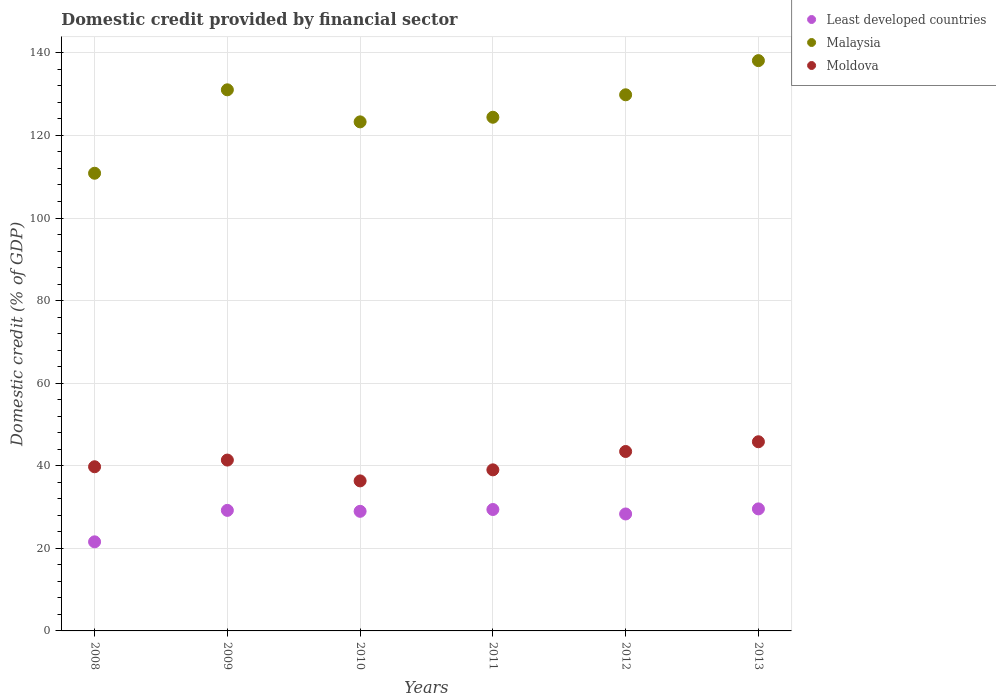What is the domestic credit in Malaysia in 2010?
Make the answer very short. 123.29. Across all years, what is the maximum domestic credit in Malaysia?
Give a very brief answer. 138.12. Across all years, what is the minimum domestic credit in Moldova?
Offer a very short reply. 36.34. In which year was the domestic credit in Malaysia maximum?
Provide a short and direct response. 2013. What is the total domestic credit in Moldova in the graph?
Provide a short and direct response. 245.76. What is the difference between the domestic credit in Moldova in 2010 and that in 2012?
Provide a succinct answer. -7.12. What is the difference between the domestic credit in Moldova in 2013 and the domestic credit in Least developed countries in 2010?
Offer a terse response. 16.85. What is the average domestic credit in Moldova per year?
Provide a succinct answer. 40.96. In the year 2013, what is the difference between the domestic credit in Malaysia and domestic credit in Moldova?
Make the answer very short. 92.31. What is the ratio of the domestic credit in Malaysia in 2009 to that in 2011?
Ensure brevity in your answer.  1.05. What is the difference between the highest and the second highest domestic credit in Malaysia?
Offer a terse response. 7.07. What is the difference between the highest and the lowest domestic credit in Malaysia?
Your answer should be compact. 27.27. In how many years, is the domestic credit in Malaysia greater than the average domestic credit in Malaysia taken over all years?
Ensure brevity in your answer.  3. Is the sum of the domestic credit in Moldova in 2011 and 2013 greater than the maximum domestic credit in Least developed countries across all years?
Provide a succinct answer. Yes. Does the domestic credit in Least developed countries monotonically increase over the years?
Give a very brief answer. No. Is the domestic credit in Least developed countries strictly greater than the domestic credit in Malaysia over the years?
Give a very brief answer. No. What is the difference between two consecutive major ticks on the Y-axis?
Offer a terse response. 20. Are the values on the major ticks of Y-axis written in scientific E-notation?
Keep it short and to the point. No. Does the graph contain any zero values?
Ensure brevity in your answer.  No. Does the graph contain grids?
Ensure brevity in your answer.  Yes. Where does the legend appear in the graph?
Ensure brevity in your answer.  Top right. How many legend labels are there?
Offer a terse response. 3. What is the title of the graph?
Your answer should be very brief. Domestic credit provided by financial sector. What is the label or title of the X-axis?
Keep it short and to the point. Years. What is the label or title of the Y-axis?
Ensure brevity in your answer.  Domestic credit (% of GDP). What is the Domestic credit (% of GDP) of Least developed countries in 2008?
Provide a short and direct response. 21.58. What is the Domestic credit (% of GDP) of Malaysia in 2008?
Give a very brief answer. 110.85. What is the Domestic credit (% of GDP) in Moldova in 2008?
Make the answer very short. 39.76. What is the Domestic credit (% of GDP) of Least developed countries in 2009?
Provide a succinct answer. 29.19. What is the Domestic credit (% of GDP) of Malaysia in 2009?
Your answer should be compact. 131.05. What is the Domestic credit (% of GDP) in Moldova in 2009?
Offer a very short reply. 41.38. What is the Domestic credit (% of GDP) of Least developed countries in 2010?
Give a very brief answer. 28.97. What is the Domestic credit (% of GDP) in Malaysia in 2010?
Make the answer very short. 123.29. What is the Domestic credit (% of GDP) in Moldova in 2010?
Your answer should be compact. 36.34. What is the Domestic credit (% of GDP) in Least developed countries in 2011?
Provide a succinct answer. 29.41. What is the Domestic credit (% of GDP) in Malaysia in 2011?
Give a very brief answer. 124.41. What is the Domestic credit (% of GDP) of Moldova in 2011?
Make the answer very short. 39.01. What is the Domestic credit (% of GDP) in Least developed countries in 2012?
Ensure brevity in your answer.  28.33. What is the Domestic credit (% of GDP) of Malaysia in 2012?
Offer a terse response. 129.85. What is the Domestic credit (% of GDP) of Moldova in 2012?
Provide a succinct answer. 43.46. What is the Domestic credit (% of GDP) of Least developed countries in 2013?
Ensure brevity in your answer.  29.55. What is the Domestic credit (% of GDP) of Malaysia in 2013?
Give a very brief answer. 138.12. What is the Domestic credit (% of GDP) of Moldova in 2013?
Make the answer very short. 45.81. Across all years, what is the maximum Domestic credit (% of GDP) in Least developed countries?
Your answer should be very brief. 29.55. Across all years, what is the maximum Domestic credit (% of GDP) of Malaysia?
Offer a very short reply. 138.12. Across all years, what is the maximum Domestic credit (% of GDP) in Moldova?
Your response must be concise. 45.81. Across all years, what is the minimum Domestic credit (% of GDP) in Least developed countries?
Give a very brief answer. 21.58. Across all years, what is the minimum Domestic credit (% of GDP) of Malaysia?
Offer a very short reply. 110.85. Across all years, what is the minimum Domestic credit (% of GDP) of Moldova?
Your answer should be very brief. 36.34. What is the total Domestic credit (% of GDP) in Least developed countries in the graph?
Ensure brevity in your answer.  167.03. What is the total Domestic credit (% of GDP) of Malaysia in the graph?
Keep it short and to the point. 757.57. What is the total Domestic credit (% of GDP) of Moldova in the graph?
Provide a succinct answer. 245.76. What is the difference between the Domestic credit (% of GDP) in Least developed countries in 2008 and that in 2009?
Keep it short and to the point. -7.62. What is the difference between the Domestic credit (% of GDP) in Malaysia in 2008 and that in 2009?
Provide a succinct answer. -20.2. What is the difference between the Domestic credit (% of GDP) in Moldova in 2008 and that in 2009?
Keep it short and to the point. -1.62. What is the difference between the Domestic credit (% of GDP) in Least developed countries in 2008 and that in 2010?
Provide a short and direct response. -7.39. What is the difference between the Domestic credit (% of GDP) of Malaysia in 2008 and that in 2010?
Offer a very short reply. -12.44. What is the difference between the Domestic credit (% of GDP) in Moldova in 2008 and that in 2010?
Offer a terse response. 3.42. What is the difference between the Domestic credit (% of GDP) of Least developed countries in 2008 and that in 2011?
Offer a terse response. -7.83. What is the difference between the Domestic credit (% of GDP) in Malaysia in 2008 and that in 2011?
Your answer should be compact. -13.56. What is the difference between the Domestic credit (% of GDP) in Moldova in 2008 and that in 2011?
Provide a succinct answer. 0.75. What is the difference between the Domestic credit (% of GDP) of Least developed countries in 2008 and that in 2012?
Provide a succinct answer. -6.75. What is the difference between the Domestic credit (% of GDP) of Malaysia in 2008 and that in 2012?
Your answer should be compact. -19. What is the difference between the Domestic credit (% of GDP) in Moldova in 2008 and that in 2012?
Keep it short and to the point. -3.7. What is the difference between the Domestic credit (% of GDP) of Least developed countries in 2008 and that in 2013?
Provide a short and direct response. -7.98. What is the difference between the Domestic credit (% of GDP) in Malaysia in 2008 and that in 2013?
Keep it short and to the point. -27.27. What is the difference between the Domestic credit (% of GDP) in Moldova in 2008 and that in 2013?
Make the answer very short. -6.05. What is the difference between the Domestic credit (% of GDP) of Least developed countries in 2009 and that in 2010?
Offer a very short reply. 0.23. What is the difference between the Domestic credit (% of GDP) of Malaysia in 2009 and that in 2010?
Keep it short and to the point. 7.76. What is the difference between the Domestic credit (% of GDP) in Moldova in 2009 and that in 2010?
Offer a terse response. 5.04. What is the difference between the Domestic credit (% of GDP) in Least developed countries in 2009 and that in 2011?
Keep it short and to the point. -0.21. What is the difference between the Domestic credit (% of GDP) of Malaysia in 2009 and that in 2011?
Offer a very short reply. 6.65. What is the difference between the Domestic credit (% of GDP) of Moldova in 2009 and that in 2011?
Your response must be concise. 2.37. What is the difference between the Domestic credit (% of GDP) of Least developed countries in 2009 and that in 2012?
Keep it short and to the point. 0.87. What is the difference between the Domestic credit (% of GDP) of Malaysia in 2009 and that in 2012?
Make the answer very short. 1.21. What is the difference between the Domestic credit (% of GDP) in Moldova in 2009 and that in 2012?
Provide a short and direct response. -2.08. What is the difference between the Domestic credit (% of GDP) of Least developed countries in 2009 and that in 2013?
Make the answer very short. -0.36. What is the difference between the Domestic credit (% of GDP) in Malaysia in 2009 and that in 2013?
Offer a terse response. -7.07. What is the difference between the Domestic credit (% of GDP) of Moldova in 2009 and that in 2013?
Give a very brief answer. -4.43. What is the difference between the Domestic credit (% of GDP) in Least developed countries in 2010 and that in 2011?
Provide a short and direct response. -0.44. What is the difference between the Domestic credit (% of GDP) in Malaysia in 2010 and that in 2011?
Provide a succinct answer. -1.12. What is the difference between the Domestic credit (% of GDP) of Moldova in 2010 and that in 2011?
Offer a terse response. -2.68. What is the difference between the Domestic credit (% of GDP) of Least developed countries in 2010 and that in 2012?
Keep it short and to the point. 0.64. What is the difference between the Domestic credit (% of GDP) in Malaysia in 2010 and that in 2012?
Give a very brief answer. -6.56. What is the difference between the Domestic credit (% of GDP) of Moldova in 2010 and that in 2012?
Ensure brevity in your answer.  -7.12. What is the difference between the Domestic credit (% of GDP) in Least developed countries in 2010 and that in 2013?
Provide a succinct answer. -0.59. What is the difference between the Domestic credit (% of GDP) in Malaysia in 2010 and that in 2013?
Make the answer very short. -14.83. What is the difference between the Domestic credit (% of GDP) in Moldova in 2010 and that in 2013?
Provide a short and direct response. -9.48. What is the difference between the Domestic credit (% of GDP) in Least developed countries in 2011 and that in 2012?
Keep it short and to the point. 1.08. What is the difference between the Domestic credit (% of GDP) in Malaysia in 2011 and that in 2012?
Your answer should be very brief. -5.44. What is the difference between the Domestic credit (% of GDP) of Moldova in 2011 and that in 2012?
Keep it short and to the point. -4.45. What is the difference between the Domestic credit (% of GDP) in Least developed countries in 2011 and that in 2013?
Give a very brief answer. -0.15. What is the difference between the Domestic credit (% of GDP) of Malaysia in 2011 and that in 2013?
Your answer should be compact. -13.71. What is the difference between the Domestic credit (% of GDP) of Moldova in 2011 and that in 2013?
Provide a short and direct response. -6.8. What is the difference between the Domestic credit (% of GDP) of Least developed countries in 2012 and that in 2013?
Your answer should be compact. -1.23. What is the difference between the Domestic credit (% of GDP) of Malaysia in 2012 and that in 2013?
Your answer should be very brief. -8.27. What is the difference between the Domestic credit (% of GDP) of Moldova in 2012 and that in 2013?
Make the answer very short. -2.35. What is the difference between the Domestic credit (% of GDP) of Least developed countries in 2008 and the Domestic credit (% of GDP) of Malaysia in 2009?
Offer a very short reply. -109.48. What is the difference between the Domestic credit (% of GDP) in Least developed countries in 2008 and the Domestic credit (% of GDP) in Moldova in 2009?
Ensure brevity in your answer.  -19.8. What is the difference between the Domestic credit (% of GDP) in Malaysia in 2008 and the Domestic credit (% of GDP) in Moldova in 2009?
Give a very brief answer. 69.47. What is the difference between the Domestic credit (% of GDP) in Least developed countries in 2008 and the Domestic credit (% of GDP) in Malaysia in 2010?
Offer a very short reply. -101.71. What is the difference between the Domestic credit (% of GDP) of Least developed countries in 2008 and the Domestic credit (% of GDP) of Moldova in 2010?
Offer a very short reply. -14.76. What is the difference between the Domestic credit (% of GDP) in Malaysia in 2008 and the Domestic credit (% of GDP) in Moldova in 2010?
Provide a succinct answer. 74.51. What is the difference between the Domestic credit (% of GDP) of Least developed countries in 2008 and the Domestic credit (% of GDP) of Malaysia in 2011?
Give a very brief answer. -102.83. What is the difference between the Domestic credit (% of GDP) of Least developed countries in 2008 and the Domestic credit (% of GDP) of Moldova in 2011?
Make the answer very short. -17.43. What is the difference between the Domestic credit (% of GDP) in Malaysia in 2008 and the Domestic credit (% of GDP) in Moldova in 2011?
Give a very brief answer. 71.84. What is the difference between the Domestic credit (% of GDP) of Least developed countries in 2008 and the Domestic credit (% of GDP) of Malaysia in 2012?
Provide a succinct answer. -108.27. What is the difference between the Domestic credit (% of GDP) in Least developed countries in 2008 and the Domestic credit (% of GDP) in Moldova in 2012?
Make the answer very short. -21.88. What is the difference between the Domestic credit (% of GDP) in Malaysia in 2008 and the Domestic credit (% of GDP) in Moldova in 2012?
Provide a succinct answer. 67.39. What is the difference between the Domestic credit (% of GDP) of Least developed countries in 2008 and the Domestic credit (% of GDP) of Malaysia in 2013?
Keep it short and to the point. -116.54. What is the difference between the Domestic credit (% of GDP) of Least developed countries in 2008 and the Domestic credit (% of GDP) of Moldova in 2013?
Provide a short and direct response. -24.24. What is the difference between the Domestic credit (% of GDP) in Malaysia in 2008 and the Domestic credit (% of GDP) in Moldova in 2013?
Offer a very short reply. 65.03. What is the difference between the Domestic credit (% of GDP) in Least developed countries in 2009 and the Domestic credit (% of GDP) in Malaysia in 2010?
Your answer should be compact. -94.1. What is the difference between the Domestic credit (% of GDP) in Least developed countries in 2009 and the Domestic credit (% of GDP) in Moldova in 2010?
Give a very brief answer. -7.14. What is the difference between the Domestic credit (% of GDP) of Malaysia in 2009 and the Domestic credit (% of GDP) of Moldova in 2010?
Offer a very short reply. 94.72. What is the difference between the Domestic credit (% of GDP) in Least developed countries in 2009 and the Domestic credit (% of GDP) in Malaysia in 2011?
Offer a terse response. -95.21. What is the difference between the Domestic credit (% of GDP) of Least developed countries in 2009 and the Domestic credit (% of GDP) of Moldova in 2011?
Your answer should be compact. -9.82. What is the difference between the Domestic credit (% of GDP) of Malaysia in 2009 and the Domestic credit (% of GDP) of Moldova in 2011?
Ensure brevity in your answer.  92.04. What is the difference between the Domestic credit (% of GDP) in Least developed countries in 2009 and the Domestic credit (% of GDP) in Malaysia in 2012?
Give a very brief answer. -100.65. What is the difference between the Domestic credit (% of GDP) in Least developed countries in 2009 and the Domestic credit (% of GDP) in Moldova in 2012?
Your answer should be very brief. -14.27. What is the difference between the Domestic credit (% of GDP) of Malaysia in 2009 and the Domestic credit (% of GDP) of Moldova in 2012?
Offer a terse response. 87.59. What is the difference between the Domestic credit (% of GDP) in Least developed countries in 2009 and the Domestic credit (% of GDP) in Malaysia in 2013?
Provide a short and direct response. -108.93. What is the difference between the Domestic credit (% of GDP) in Least developed countries in 2009 and the Domestic credit (% of GDP) in Moldova in 2013?
Your response must be concise. -16.62. What is the difference between the Domestic credit (% of GDP) in Malaysia in 2009 and the Domestic credit (% of GDP) in Moldova in 2013?
Offer a terse response. 85.24. What is the difference between the Domestic credit (% of GDP) of Least developed countries in 2010 and the Domestic credit (% of GDP) of Malaysia in 2011?
Ensure brevity in your answer.  -95.44. What is the difference between the Domestic credit (% of GDP) of Least developed countries in 2010 and the Domestic credit (% of GDP) of Moldova in 2011?
Ensure brevity in your answer.  -10.04. What is the difference between the Domestic credit (% of GDP) of Malaysia in 2010 and the Domestic credit (% of GDP) of Moldova in 2011?
Offer a terse response. 84.28. What is the difference between the Domestic credit (% of GDP) in Least developed countries in 2010 and the Domestic credit (% of GDP) in Malaysia in 2012?
Offer a terse response. -100.88. What is the difference between the Domestic credit (% of GDP) in Least developed countries in 2010 and the Domestic credit (% of GDP) in Moldova in 2012?
Your answer should be very brief. -14.49. What is the difference between the Domestic credit (% of GDP) in Malaysia in 2010 and the Domestic credit (% of GDP) in Moldova in 2012?
Give a very brief answer. 79.83. What is the difference between the Domestic credit (% of GDP) of Least developed countries in 2010 and the Domestic credit (% of GDP) of Malaysia in 2013?
Provide a succinct answer. -109.15. What is the difference between the Domestic credit (% of GDP) of Least developed countries in 2010 and the Domestic credit (% of GDP) of Moldova in 2013?
Provide a succinct answer. -16.85. What is the difference between the Domestic credit (% of GDP) of Malaysia in 2010 and the Domestic credit (% of GDP) of Moldova in 2013?
Make the answer very short. 77.48. What is the difference between the Domestic credit (% of GDP) of Least developed countries in 2011 and the Domestic credit (% of GDP) of Malaysia in 2012?
Give a very brief answer. -100.44. What is the difference between the Domestic credit (% of GDP) in Least developed countries in 2011 and the Domestic credit (% of GDP) in Moldova in 2012?
Ensure brevity in your answer.  -14.05. What is the difference between the Domestic credit (% of GDP) of Malaysia in 2011 and the Domestic credit (% of GDP) of Moldova in 2012?
Give a very brief answer. 80.95. What is the difference between the Domestic credit (% of GDP) of Least developed countries in 2011 and the Domestic credit (% of GDP) of Malaysia in 2013?
Give a very brief answer. -108.71. What is the difference between the Domestic credit (% of GDP) of Least developed countries in 2011 and the Domestic credit (% of GDP) of Moldova in 2013?
Provide a short and direct response. -16.41. What is the difference between the Domestic credit (% of GDP) of Malaysia in 2011 and the Domestic credit (% of GDP) of Moldova in 2013?
Provide a succinct answer. 78.59. What is the difference between the Domestic credit (% of GDP) of Least developed countries in 2012 and the Domestic credit (% of GDP) of Malaysia in 2013?
Provide a succinct answer. -109.79. What is the difference between the Domestic credit (% of GDP) in Least developed countries in 2012 and the Domestic credit (% of GDP) in Moldova in 2013?
Ensure brevity in your answer.  -17.49. What is the difference between the Domestic credit (% of GDP) of Malaysia in 2012 and the Domestic credit (% of GDP) of Moldova in 2013?
Provide a succinct answer. 84.03. What is the average Domestic credit (% of GDP) in Least developed countries per year?
Offer a terse response. 27.84. What is the average Domestic credit (% of GDP) of Malaysia per year?
Offer a very short reply. 126.26. What is the average Domestic credit (% of GDP) of Moldova per year?
Ensure brevity in your answer.  40.96. In the year 2008, what is the difference between the Domestic credit (% of GDP) in Least developed countries and Domestic credit (% of GDP) in Malaysia?
Make the answer very short. -89.27. In the year 2008, what is the difference between the Domestic credit (% of GDP) in Least developed countries and Domestic credit (% of GDP) in Moldova?
Offer a very short reply. -18.18. In the year 2008, what is the difference between the Domestic credit (% of GDP) of Malaysia and Domestic credit (% of GDP) of Moldova?
Provide a succinct answer. 71.09. In the year 2009, what is the difference between the Domestic credit (% of GDP) of Least developed countries and Domestic credit (% of GDP) of Malaysia?
Your response must be concise. -101.86. In the year 2009, what is the difference between the Domestic credit (% of GDP) of Least developed countries and Domestic credit (% of GDP) of Moldova?
Offer a very short reply. -12.19. In the year 2009, what is the difference between the Domestic credit (% of GDP) in Malaysia and Domestic credit (% of GDP) in Moldova?
Your answer should be very brief. 89.67. In the year 2010, what is the difference between the Domestic credit (% of GDP) in Least developed countries and Domestic credit (% of GDP) in Malaysia?
Your answer should be very brief. -94.32. In the year 2010, what is the difference between the Domestic credit (% of GDP) of Least developed countries and Domestic credit (% of GDP) of Moldova?
Offer a terse response. -7.37. In the year 2010, what is the difference between the Domestic credit (% of GDP) of Malaysia and Domestic credit (% of GDP) of Moldova?
Ensure brevity in your answer.  86.96. In the year 2011, what is the difference between the Domestic credit (% of GDP) of Least developed countries and Domestic credit (% of GDP) of Malaysia?
Provide a short and direct response. -95. In the year 2011, what is the difference between the Domestic credit (% of GDP) in Least developed countries and Domestic credit (% of GDP) in Moldova?
Your answer should be compact. -9.6. In the year 2011, what is the difference between the Domestic credit (% of GDP) in Malaysia and Domestic credit (% of GDP) in Moldova?
Keep it short and to the point. 85.4. In the year 2012, what is the difference between the Domestic credit (% of GDP) of Least developed countries and Domestic credit (% of GDP) of Malaysia?
Give a very brief answer. -101.52. In the year 2012, what is the difference between the Domestic credit (% of GDP) of Least developed countries and Domestic credit (% of GDP) of Moldova?
Your answer should be very brief. -15.13. In the year 2012, what is the difference between the Domestic credit (% of GDP) of Malaysia and Domestic credit (% of GDP) of Moldova?
Your answer should be very brief. 86.39. In the year 2013, what is the difference between the Domestic credit (% of GDP) in Least developed countries and Domestic credit (% of GDP) in Malaysia?
Give a very brief answer. -108.57. In the year 2013, what is the difference between the Domestic credit (% of GDP) in Least developed countries and Domestic credit (% of GDP) in Moldova?
Your answer should be very brief. -16.26. In the year 2013, what is the difference between the Domestic credit (% of GDP) in Malaysia and Domestic credit (% of GDP) in Moldova?
Offer a terse response. 92.31. What is the ratio of the Domestic credit (% of GDP) in Least developed countries in 2008 to that in 2009?
Keep it short and to the point. 0.74. What is the ratio of the Domestic credit (% of GDP) of Malaysia in 2008 to that in 2009?
Your answer should be compact. 0.85. What is the ratio of the Domestic credit (% of GDP) of Moldova in 2008 to that in 2009?
Ensure brevity in your answer.  0.96. What is the ratio of the Domestic credit (% of GDP) of Least developed countries in 2008 to that in 2010?
Keep it short and to the point. 0.74. What is the ratio of the Domestic credit (% of GDP) in Malaysia in 2008 to that in 2010?
Your response must be concise. 0.9. What is the ratio of the Domestic credit (% of GDP) in Moldova in 2008 to that in 2010?
Provide a succinct answer. 1.09. What is the ratio of the Domestic credit (% of GDP) of Least developed countries in 2008 to that in 2011?
Your answer should be compact. 0.73. What is the ratio of the Domestic credit (% of GDP) of Malaysia in 2008 to that in 2011?
Your response must be concise. 0.89. What is the ratio of the Domestic credit (% of GDP) of Moldova in 2008 to that in 2011?
Make the answer very short. 1.02. What is the ratio of the Domestic credit (% of GDP) of Least developed countries in 2008 to that in 2012?
Make the answer very short. 0.76. What is the ratio of the Domestic credit (% of GDP) of Malaysia in 2008 to that in 2012?
Your answer should be compact. 0.85. What is the ratio of the Domestic credit (% of GDP) in Moldova in 2008 to that in 2012?
Your response must be concise. 0.91. What is the ratio of the Domestic credit (% of GDP) of Least developed countries in 2008 to that in 2013?
Make the answer very short. 0.73. What is the ratio of the Domestic credit (% of GDP) of Malaysia in 2008 to that in 2013?
Provide a short and direct response. 0.8. What is the ratio of the Domestic credit (% of GDP) of Moldova in 2008 to that in 2013?
Keep it short and to the point. 0.87. What is the ratio of the Domestic credit (% of GDP) in Least developed countries in 2009 to that in 2010?
Your response must be concise. 1.01. What is the ratio of the Domestic credit (% of GDP) of Malaysia in 2009 to that in 2010?
Offer a terse response. 1.06. What is the ratio of the Domestic credit (% of GDP) of Moldova in 2009 to that in 2010?
Your answer should be compact. 1.14. What is the ratio of the Domestic credit (% of GDP) in Malaysia in 2009 to that in 2011?
Provide a succinct answer. 1.05. What is the ratio of the Domestic credit (% of GDP) of Moldova in 2009 to that in 2011?
Provide a succinct answer. 1.06. What is the ratio of the Domestic credit (% of GDP) of Least developed countries in 2009 to that in 2012?
Keep it short and to the point. 1.03. What is the ratio of the Domestic credit (% of GDP) in Malaysia in 2009 to that in 2012?
Your answer should be compact. 1.01. What is the ratio of the Domestic credit (% of GDP) of Moldova in 2009 to that in 2012?
Provide a short and direct response. 0.95. What is the ratio of the Domestic credit (% of GDP) in Least developed countries in 2009 to that in 2013?
Make the answer very short. 0.99. What is the ratio of the Domestic credit (% of GDP) of Malaysia in 2009 to that in 2013?
Your answer should be compact. 0.95. What is the ratio of the Domestic credit (% of GDP) of Moldova in 2009 to that in 2013?
Keep it short and to the point. 0.9. What is the ratio of the Domestic credit (% of GDP) of Least developed countries in 2010 to that in 2011?
Ensure brevity in your answer.  0.98. What is the ratio of the Domestic credit (% of GDP) in Malaysia in 2010 to that in 2011?
Offer a very short reply. 0.99. What is the ratio of the Domestic credit (% of GDP) in Moldova in 2010 to that in 2011?
Offer a very short reply. 0.93. What is the ratio of the Domestic credit (% of GDP) of Least developed countries in 2010 to that in 2012?
Provide a succinct answer. 1.02. What is the ratio of the Domestic credit (% of GDP) of Malaysia in 2010 to that in 2012?
Offer a terse response. 0.95. What is the ratio of the Domestic credit (% of GDP) in Moldova in 2010 to that in 2012?
Give a very brief answer. 0.84. What is the ratio of the Domestic credit (% of GDP) of Least developed countries in 2010 to that in 2013?
Your answer should be compact. 0.98. What is the ratio of the Domestic credit (% of GDP) in Malaysia in 2010 to that in 2013?
Your response must be concise. 0.89. What is the ratio of the Domestic credit (% of GDP) in Moldova in 2010 to that in 2013?
Provide a succinct answer. 0.79. What is the ratio of the Domestic credit (% of GDP) of Least developed countries in 2011 to that in 2012?
Give a very brief answer. 1.04. What is the ratio of the Domestic credit (% of GDP) in Malaysia in 2011 to that in 2012?
Your answer should be very brief. 0.96. What is the ratio of the Domestic credit (% of GDP) in Moldova in 2011 to that in 2012?
Offer a very short reply. 0.9. What is the ratio of the Domestic credit (% of GDP) in Least developed countries in 2011 to that in 2013?
Your response must be concise. 0.99. What is the ratio of the Domestic credit (% of GDP) of Malaysia in 2011 to that in 2013?
Give a very brief answer. 0.9. What is the ratio of the Domestic credit (% of GDP) of Moldova in 2011 to that in 2013?
Ensure brevity in your answer.  0.85. What is the ratio of the Domestic credit (% of GDP) in Least developed countries in 2012 to that in 2013?
Your response must be concise. 0.96. What is the ratio of the Domestic credit (% of GDP) in Malaysia in 2012 to that in 2013?
Provide a short and direct response. 0.94. What is the ratio of the Domestic credit (% of GDP) in Moldova in 2012 to that in 2013?
Make the answer very short. 0.95. What is the difference between the highest and the second highest Domestic credit (% of GDP) in Least developed countries?
Provide a short and direct response. 0.15. What is the difference between the highest and the second highest Domestic credit (% of GDP) of Malaysia?
Your answer should be compact. 7.07. What is the difference between the highest and the second highest Domestic credit (% of GDP) in Moldova?
Make the answer very short. 2.35. What is the difference between the highest and the lowest Domestic credit (% of GDP) of Least developed countries?
Provide a succinct answer. 7.98. What is the difference between the highest and the lowest Domestic credit (% of GDP) of Malaysia?
Your response must be concise. 27.27. What is the difference between the highest and the lowest Domestic credit (% of GDP) in Moldova?
Make the answer very short. 9.48. 